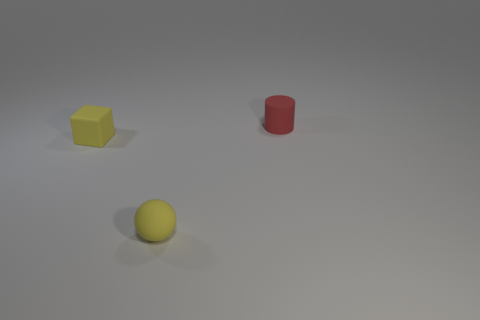Add 3 small red rubber objects. How many objects exist? 6 Subtract all blocks. How many objects are left? 2 Add 1 tiny rubber spheres. How many tiny rubber spheres exist? 2 Subtract 0 red blocks. How many objects are left? 3 Subtract all large purple shiny blocks. Subtract all rubber blocks. How many objects are left? 2 Add 1 red matte cylinders. How many red matte cylinders are left? 2 